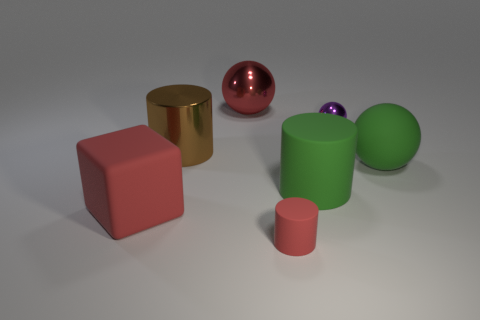There is a large cube that is the same color as the small cylinder; what is its material?
Make the answer very short. Rubber. How many matte cylinders are the same color as the large shiny cylinder?
Ensure brevity in your answer.  0. There is a red matte object that is on the left side of the big red object that is behind the large block; what is its shape?
Your response must be concise. Cube. Are there any large objects that have the same shape as the small red object?
Ensure brevity in your answer.  Yes. There is a rubber ball; is it the same color as the rubber cylinder behind the small red cylinder?
Your response must be concise. Yes. What size is the rubber cylinder that is the same color as the big rubber sphere?
Give a very brief answer. Large. Is there a rubber cube that has the same size as the red metallic sphere?
Provide a succinct answer. Yes. Does the tiny sphere have the same material as the big green object to the right of the tiny metallic ball?
Offer a terse response. No. Are there more cyan matte objects than big matte cubes?
Make the answer very short. No. What number of cylinders are either metallic things or big brown metal objects?
Provide a succinct answer. 1. 